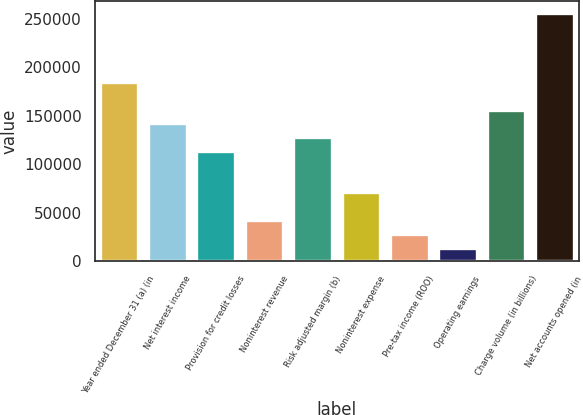Convert chart. <chart><loc_0><loc_0><loc_500><loc_500><bar_chart><fcel>Year ended December 31 (a) (in<fcel>Net interest income<fcel>Provision for credit losses<fcel>Noninterest revenue<fcel>Risk adjusted margin (b)<fcel>Noninterest expense<fcel>Pre-tax income (ROO)<fcel>Operating earnings<fcel>Charge volume (in billions)<fcel>Net accounts opened (in<nl><fcel>184944<fcel>142265<fcel>113812<fcel>42680.4<fcel>128039<fcel>71133.1<fcel>28454<fcel>14227.6<fcel>156491<fcel>256076<nl></chart> 